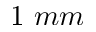Convert formula to latex. <formula><loc_0><loc_0><loc_500><loc_500>1 \ m m</formula> 